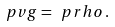Convert formula to latex. <formula><loc_0><loc_0><loc_500><loc_500>\ p v g = \ p r h o \, .</formula> 